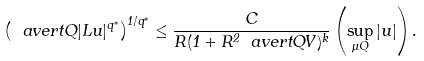Convert formula to latex. <formula><loc_0><loc_0><loc_500><loc_500>\left ( \ a v e r t { Q } | L u | ^ { q ^ { * } } \right ) ^ { 1 / q ^ { * } } \leq \frac { C } { R ( 1 + R ^ { 2 } \ a v e r t { Q } V ) ^ { k } } \left ( \sup _ { \mu Q } | u | \right ) .</formula> 